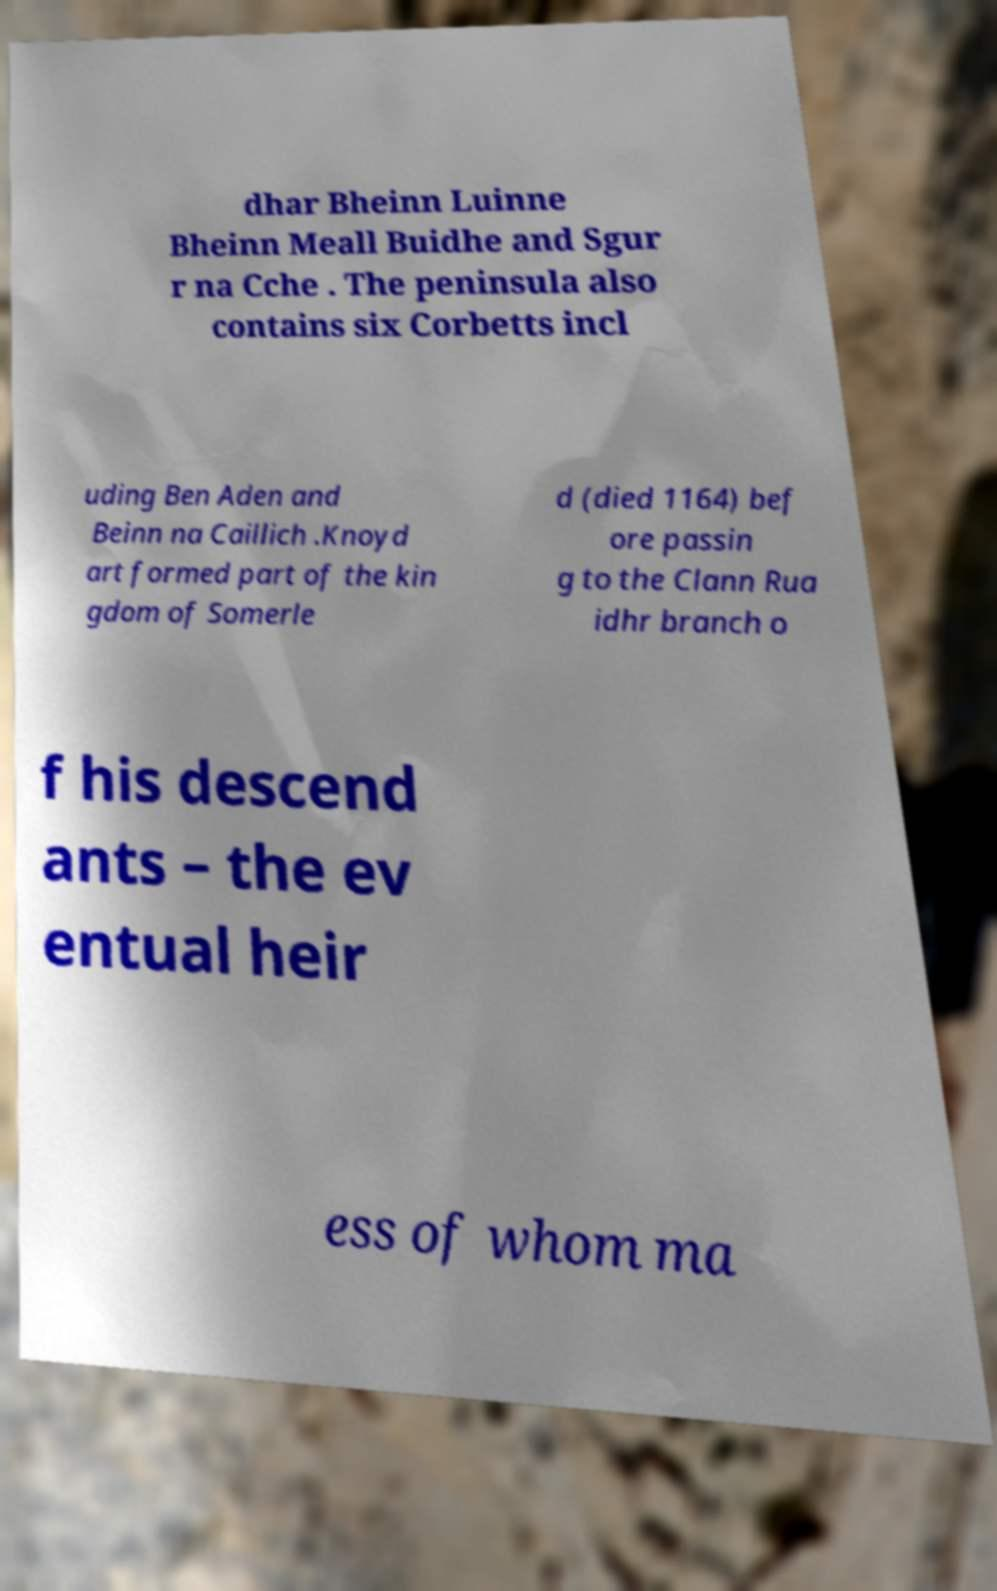Please read and relay the text visible in this image. What does it say? dhar Bheinn Luinne Bheinn Meall Buidhe and Sgur r na Cche . The peninsula also contains six Corbetts incl uding Ben Aden and Beinn na Caillich .Knoyd art formed part of the kin gdom of Somerle d (died 1164) bef ore passin g to the Clann Rua idhr branch o f his descend ants – the ev entual heir ess of whom ma 